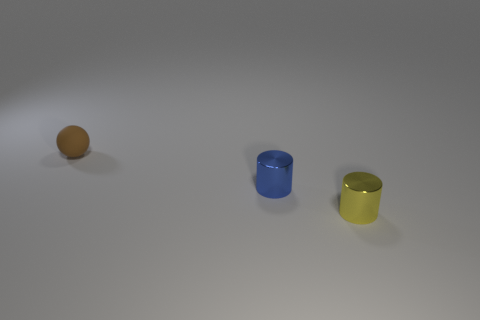What materials do these objects seem to be made of? The object on the left appears to be a small rubber ball, while the blue and yellow objects seem like cylindrical containers potentially made of plastic or metal, each with a reflective surface. 